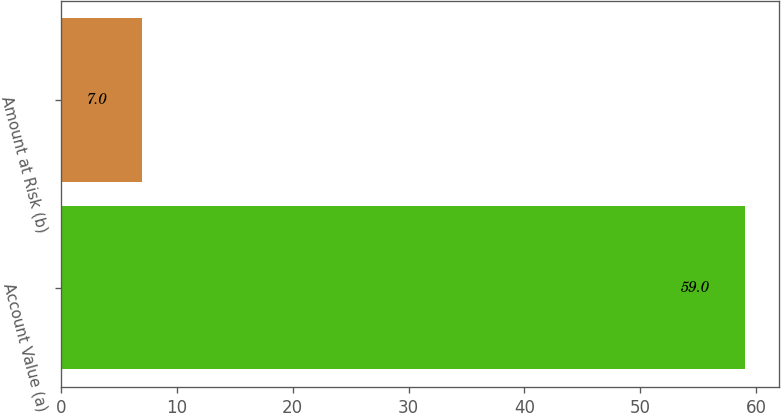Convert chart. <chart><loc_0><loc_0><loc_500><loc_500><bar_chart><fcel>Account Value (a)<fcel>Amount at Risk (b)<nl><fcel>59<fcel>7<nl></chart> 